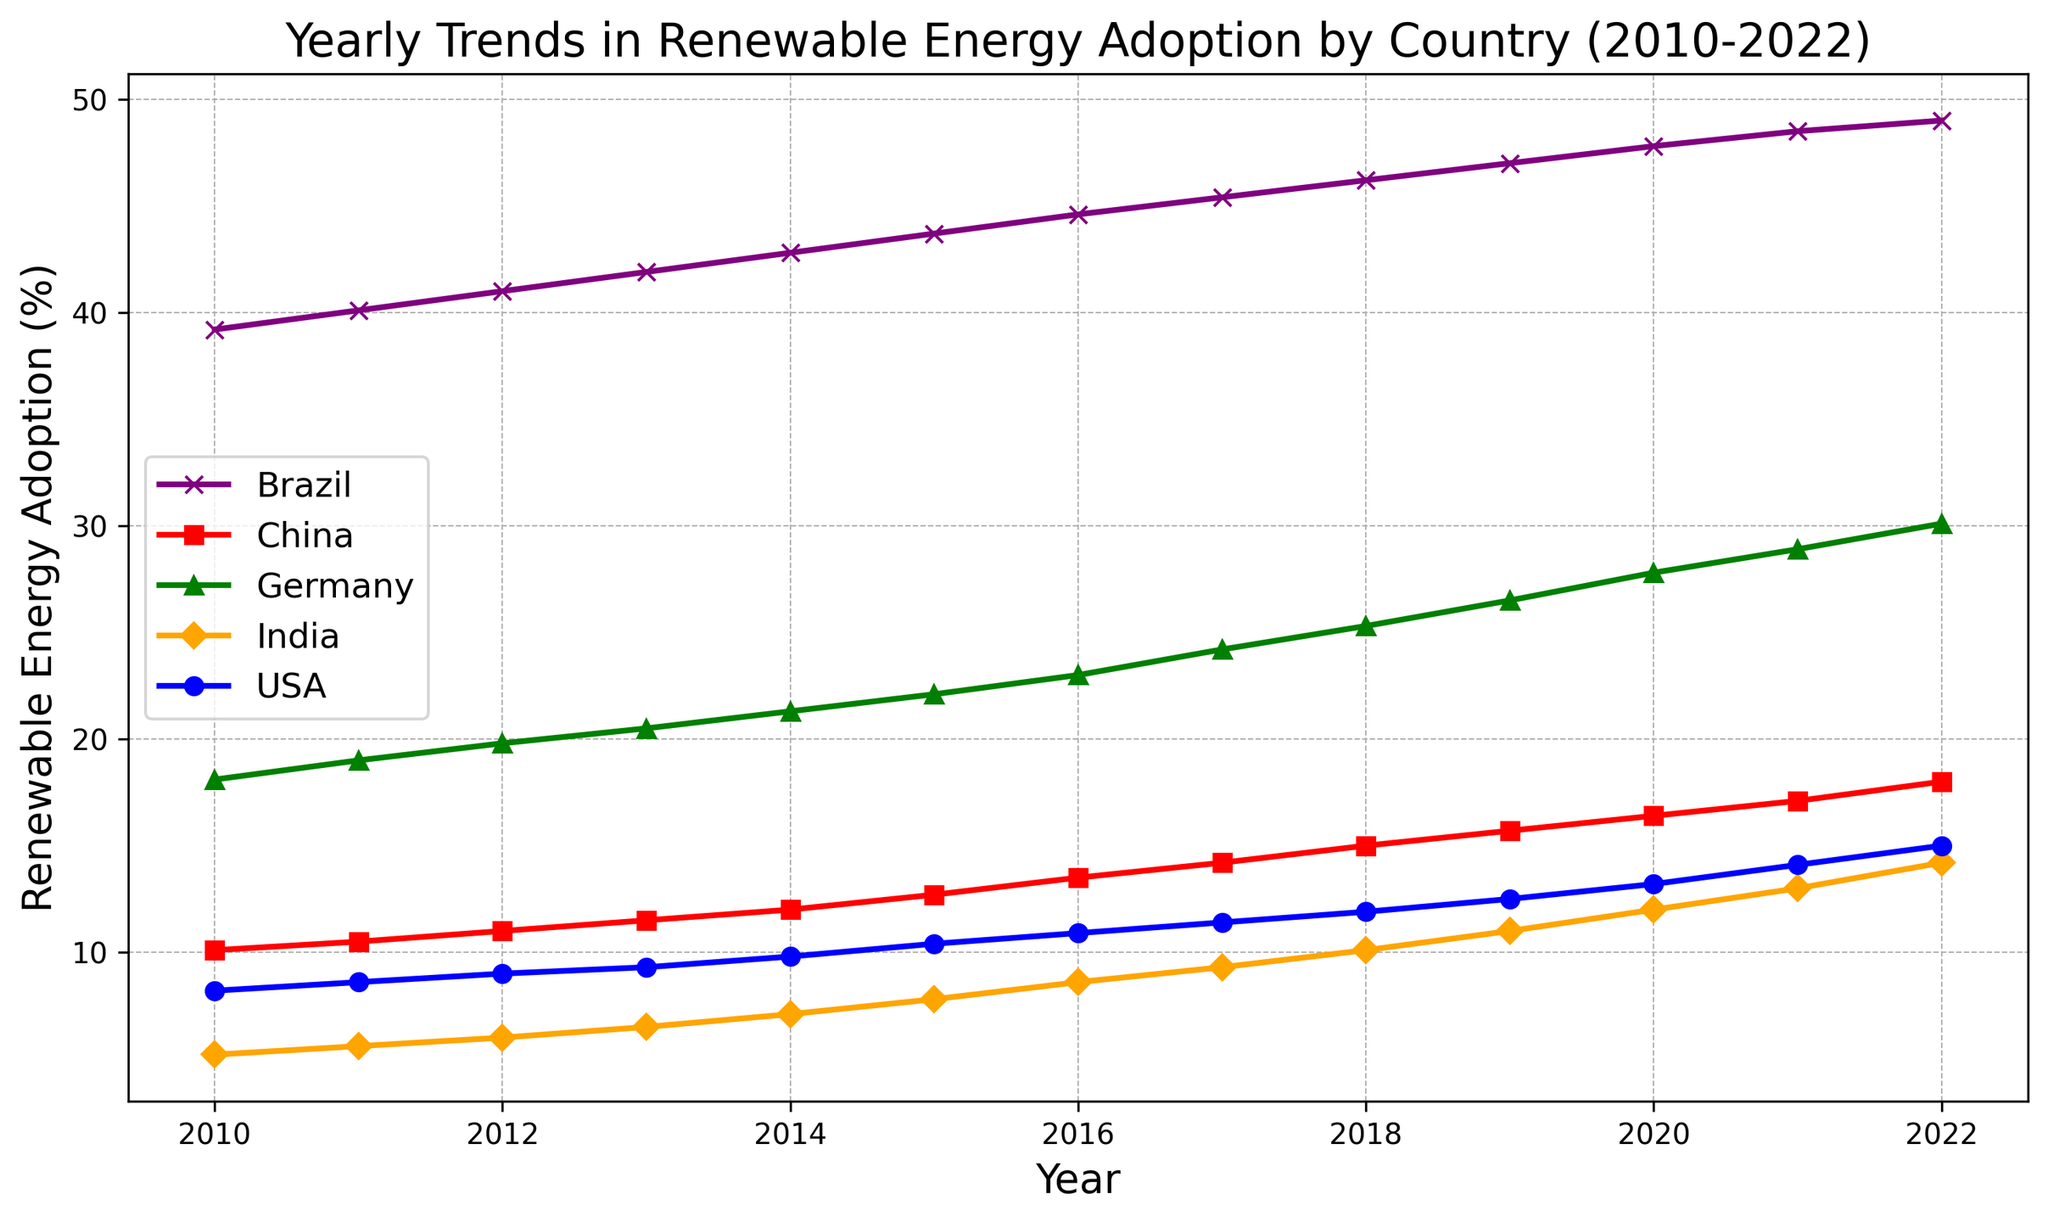What's the trend of renewable energy adoption in Germany? The line for Germany consistently goes upwards from 2010 to 2022, indicating a steady increase each year.
Answer: Steady increase Which country had the highest renewable energy adoption in 2022? The line representing Brazil reaches the highest point in 2022, surpassing all other countries.
Answer: Brazil Between 2010 and 2022, which country had the most consistent yearly increase in renewable energy adoption? Both Germany and Brazil show very steady yearly increases with smooth, upward lines. By comparing, Germany's increase is slightly smoother without any noticeable fluctuations.
Answer: Germany What is the difference in renewable energy adoption between the USA and China in 2022? In 2022, the USA's adoption rate is 15.0%, and China's is 18.0%. The difference is calculated as 18.0 - 15.0.
Answer: 3.0% How does India's renewable energy adoption in 2020 compare to the USA's in the same year? In 2020, the plot shows India at 12.0% and the USA at 13.2%. India's adoption rate is 1.2 percentage points lower than the USA's.
Answer: 1.2% lower Looking at the data, which country had the fastest increase in renewable energy adoption between 2010 and 2022? Calculate the net increase for each country from 2010 to 2022. The increases are:
- USA: 15.0% - 8.2% = 6.8%
- China: 18.0% - 10.1% = 7.9%
- Germany: 30.1% - 18.1% = 12.0%
- India: 14.2% - 5.2% = 9.0%
- Brazil: 49.0% - 39.2% = 9.8%
Germany had the fastest increase.
Answer: Germany Which country's renewable energy adoption line is represented using a purple color? The line with the purple color corresponds to Brazil.
Answer: Brazil In what year did Germany's renewable energy adoption surpass 25%? Identify the point on Germany's line where it crosses 25%. This occurs in 2018.
Answer: 2018 Is there any year where the renewable energy adoption rate of China equals that of Germany? Visually inspect whether China's and Germany's lines intersect at any point. They do not intersect, thus their adoption rates are never equal.
Answer: No What is the average renewable energy adoption in India from 2010 to 2022? Sum all the yearly adoption percentages for India from 2010 (5.2%) to 2022 (14.2%). The sum is 5.2 + 5.6 + 6.0 + 6.5 + 7.1 + 7.8 + 8.6 + 9.3 + 10.1 + 11.0 + 12.0 + 13.0 + 14.2 = 116.4. Divide by the number of years (13).
Answer: 8.95% Which country had a larger increase in renewable energy adoption between 2015 and 2020, the USA or China? For the USA: 2020 rate (13.2%) - 2015 rate (10.4%) = 2.8%
For China: 2020 rate (16.4%) - 2015 rate (12.7%) = 3.7%
China had a larger increase.
Answer: China 